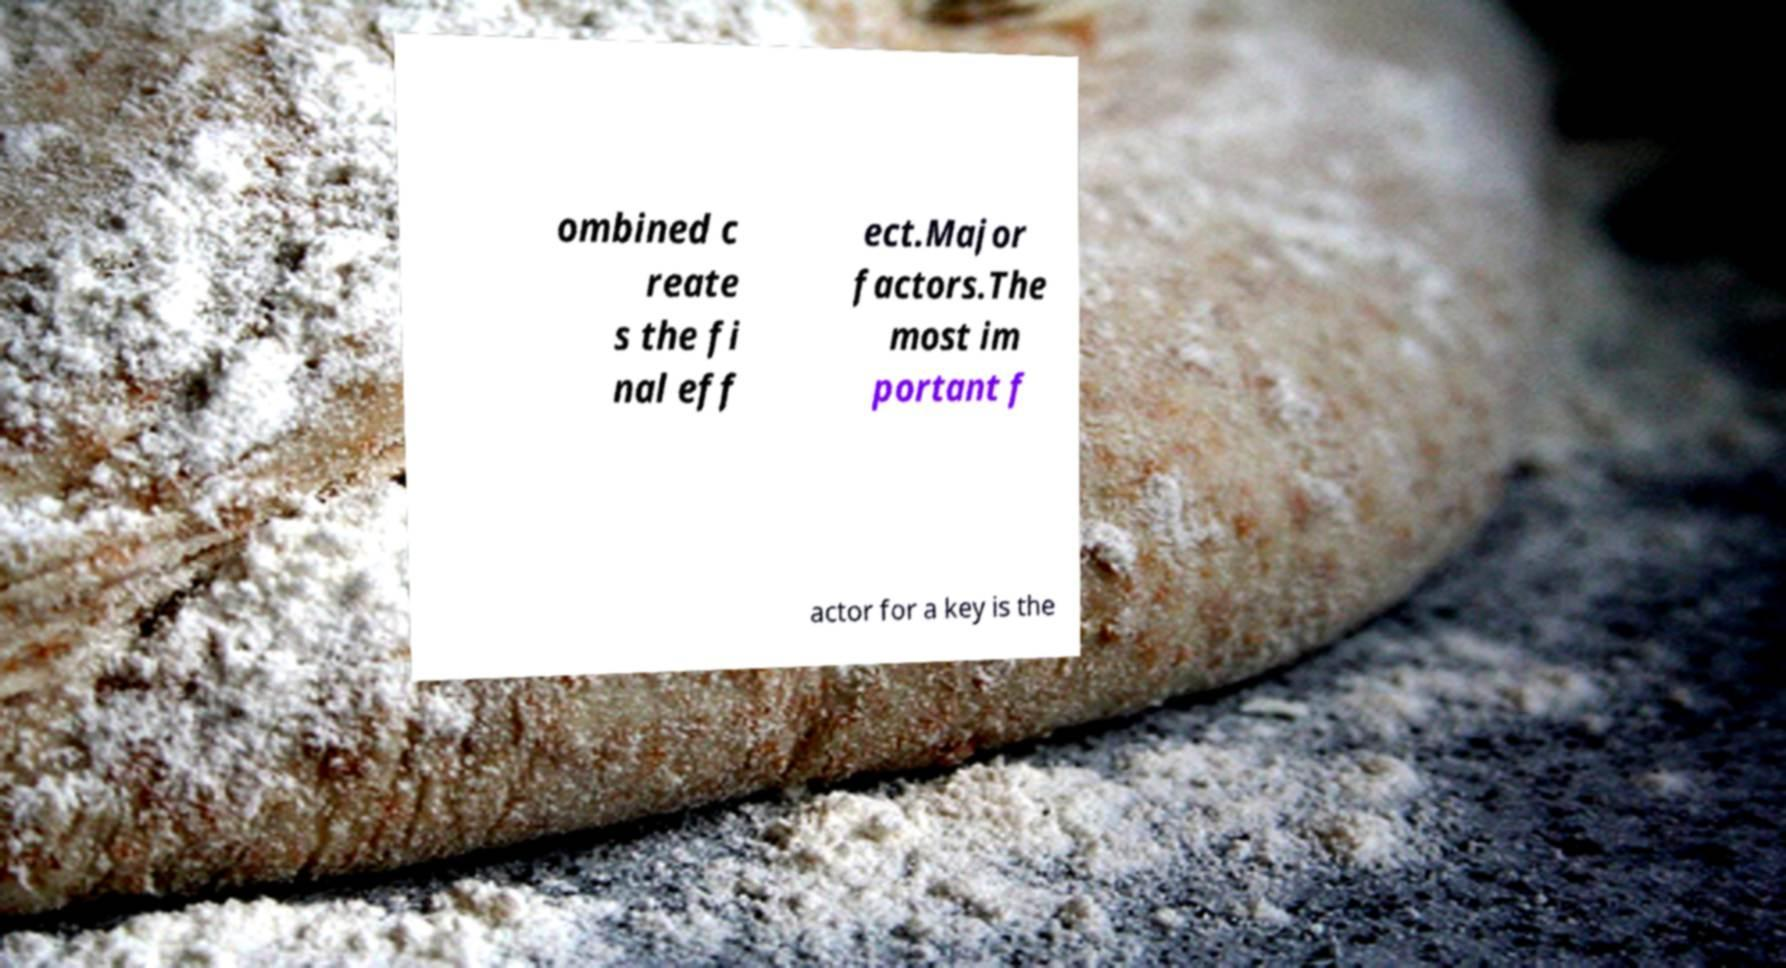What messages or text are displayed in this image? I need them in a readable, typed format. ombined c reate s the fi nal eff ect.Major factors.The most im portant f actor for a key is the 